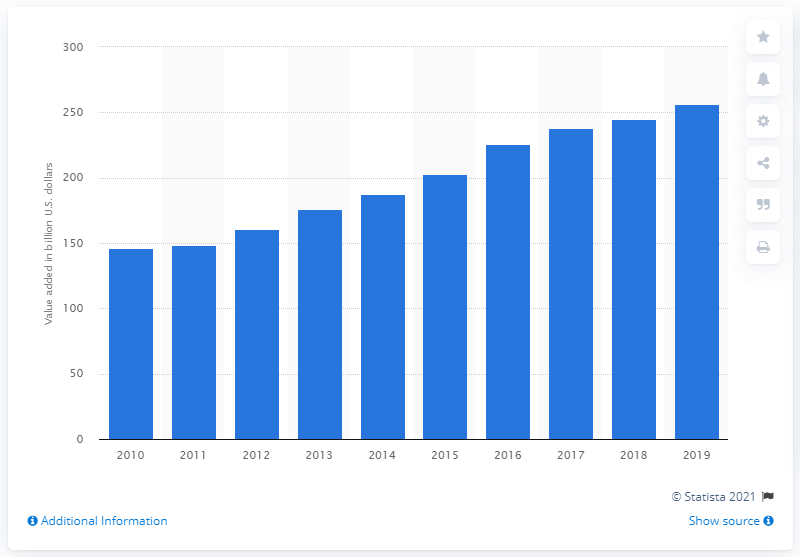Specify some key components in this picture. In 2019, the motor vehicle and parts dealers industry made a significant contribution to the growth of the U.S. economy, generating 256.6 billion dollars in revenue. 